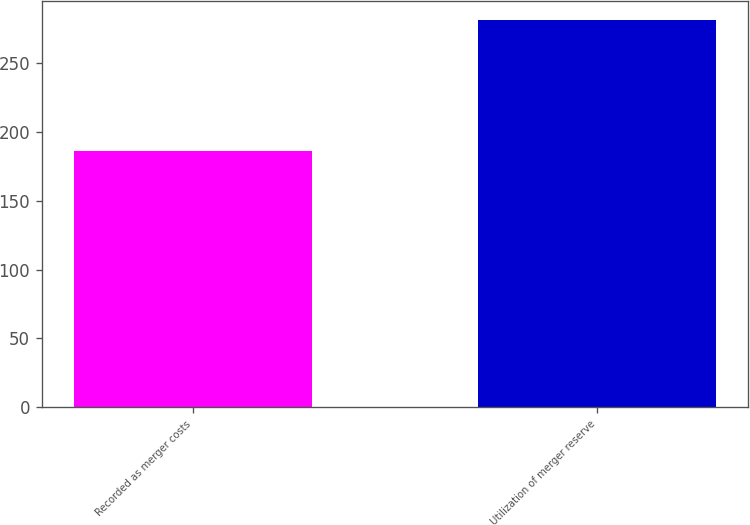Convert chart. <chart><loc_0><loc_0><loc_500><loc_500><bar_chart><fcel>Recorded as merger costs<fcel>Utilization of merger reserve<nl><fcel>186<fcel>281<nl></chart> 